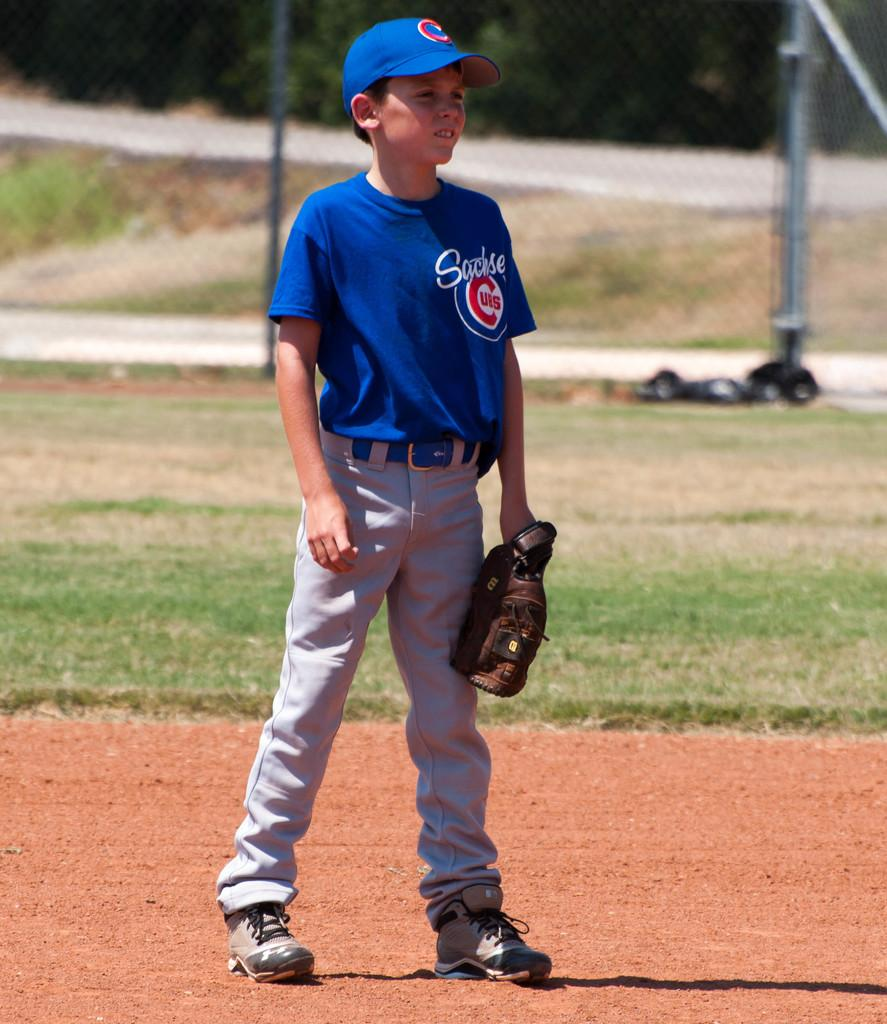<image>
Write a terse but informative summary of the picture. a little kid has a jersey with the word Cubs on it 